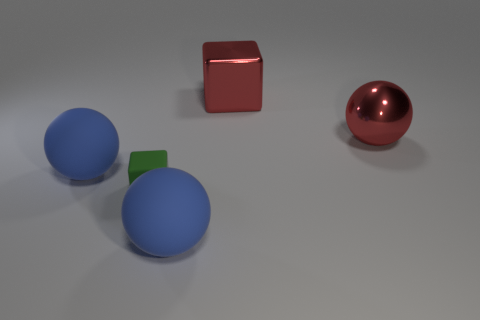Is there a big object that has the same color as the large block?
Offer a terse response. Yes. Are there fewer large red cubes to the left of the green cube than big cyan metallic blocks?
Your answer should be compact. No. There is a red thing behind the red metal sphere; is its size the same as the small matte cube?
Your answer should be very brief. No. What number of large objects are both in front of the big red block and to the right of the tiny green matte thing?
Offer a terse response. 2. How big is the blue matte ball that is right of the big sphere that is left of the small green object?
Keep it short and to the point. Large. Are there fewer cubes that are to the right of the small matte cube than balls that are in front of the metal ball?
Provide a short and direct response. Yes. There is a block that is behind the small green thing; is it the same color as the large shiny ball right of the small block?
Provide a succinct answer. Yes. There is a big sphere that is to the right of the green matte thing and behind the green thing; what is its material?
Your response must be concise. Metal. Are any large red metallic cubes visible?
Keep it short and to the point. Yes. The big object that is the same material as the red block is what shape?
Make the answer very short. Sphere. 